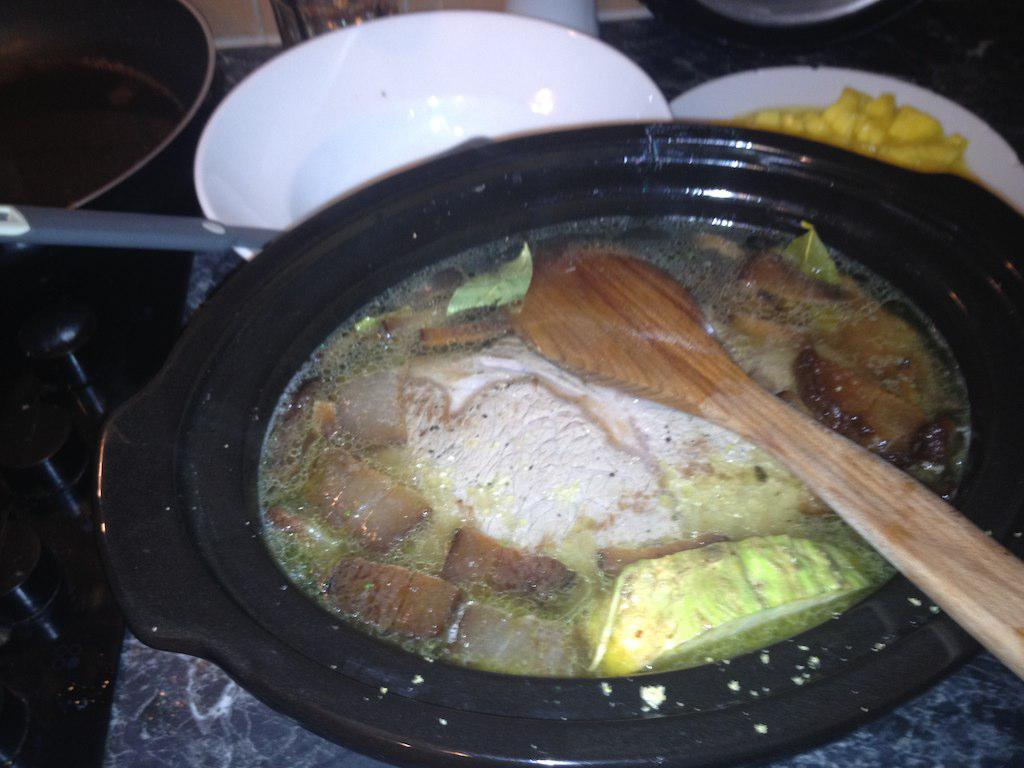What is the main subject of the image? The main subject of the image is a bowl with food items in the center. What utensil is placed next to the bowl? There is a spoon next to the bowl. Can you describe another bowl in the image? There is an empty bowl with a spoon beside it. How many cherries are on the robin's head in the image? There is no robin or cherries present in the image. 